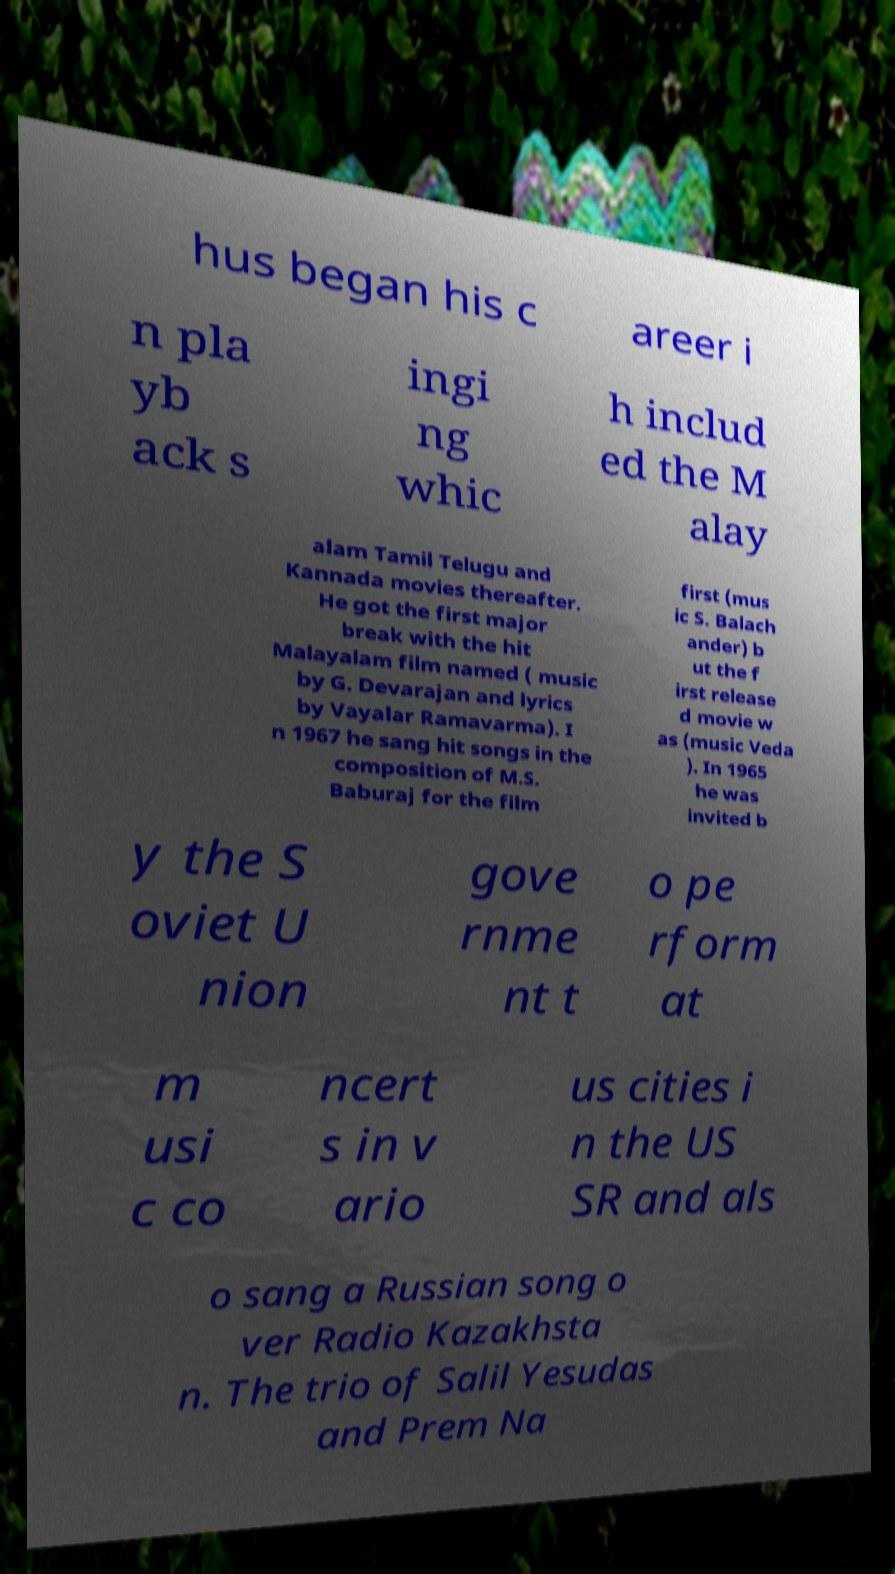Please identify and transcribe the text found in this image. hus began his c areer i n pla yb ack s ingi ng whic h includ ed the M alay alam Tamil Telugu and Kannada movies thereafter. He got the first major break with the hit Malayalam film named ( music by G. Devarajan and lyrics by Vayalar Ramavarma). I n 1967 he sang hit songs in the composition of M.S. Baburaj for the film first (mus ic S. Balach ander) b ut the f irst release d movie w as (music Veda ). In 1965 he was invited b y the S oviet U nion gove rnme nt t o pe rform at m usi c co ncert s in v ario us cities i n the US SR and als o sang a Russian song o ver Radio Kazakhsta n. The trio of Salil Yesudas and Prem Na 